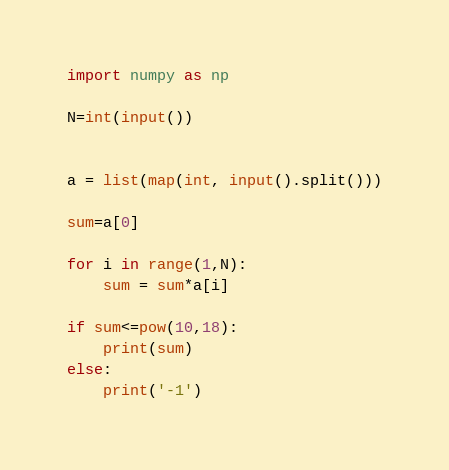<code> <loc_0><loc_0><loc_500><loc_500><_Python_>import numpy as np

N=int(input())


a = list(map(int, input().split()))

sum=a[0]

for i in range(1,N):
    sum = sum*a[i]

if sum<=pow(10,18):
    print(sum)
else:
    print('-1')
</code> 